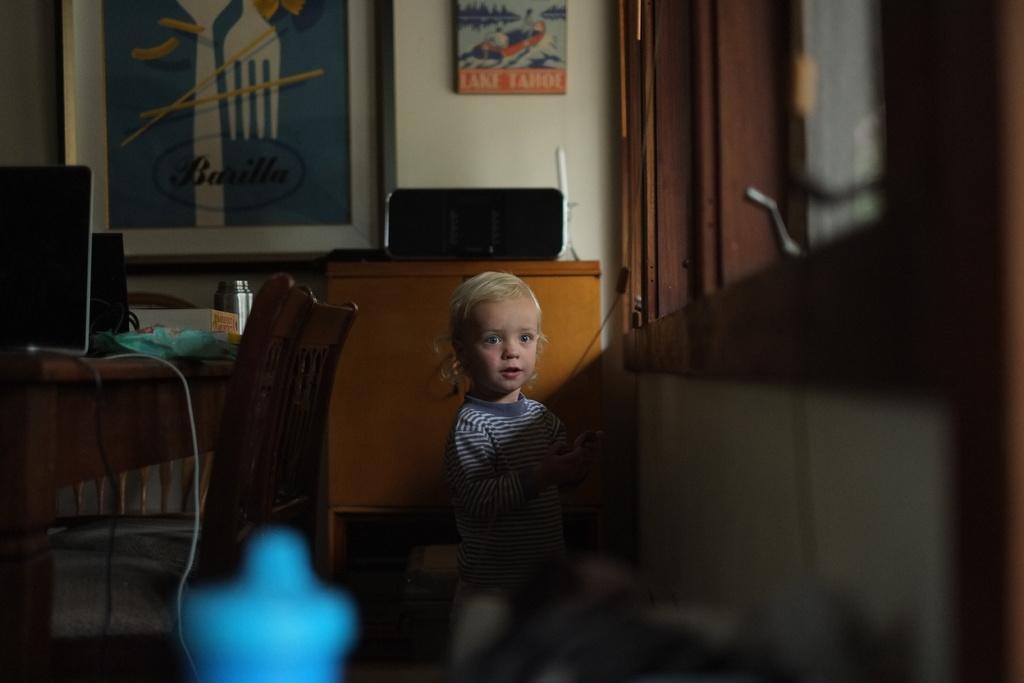Describe this image in one or two sentences. In this image i can see a girl standing, In the background i can see a wall, a photo frame, a door, a table on which there are some objects and few chairs. 